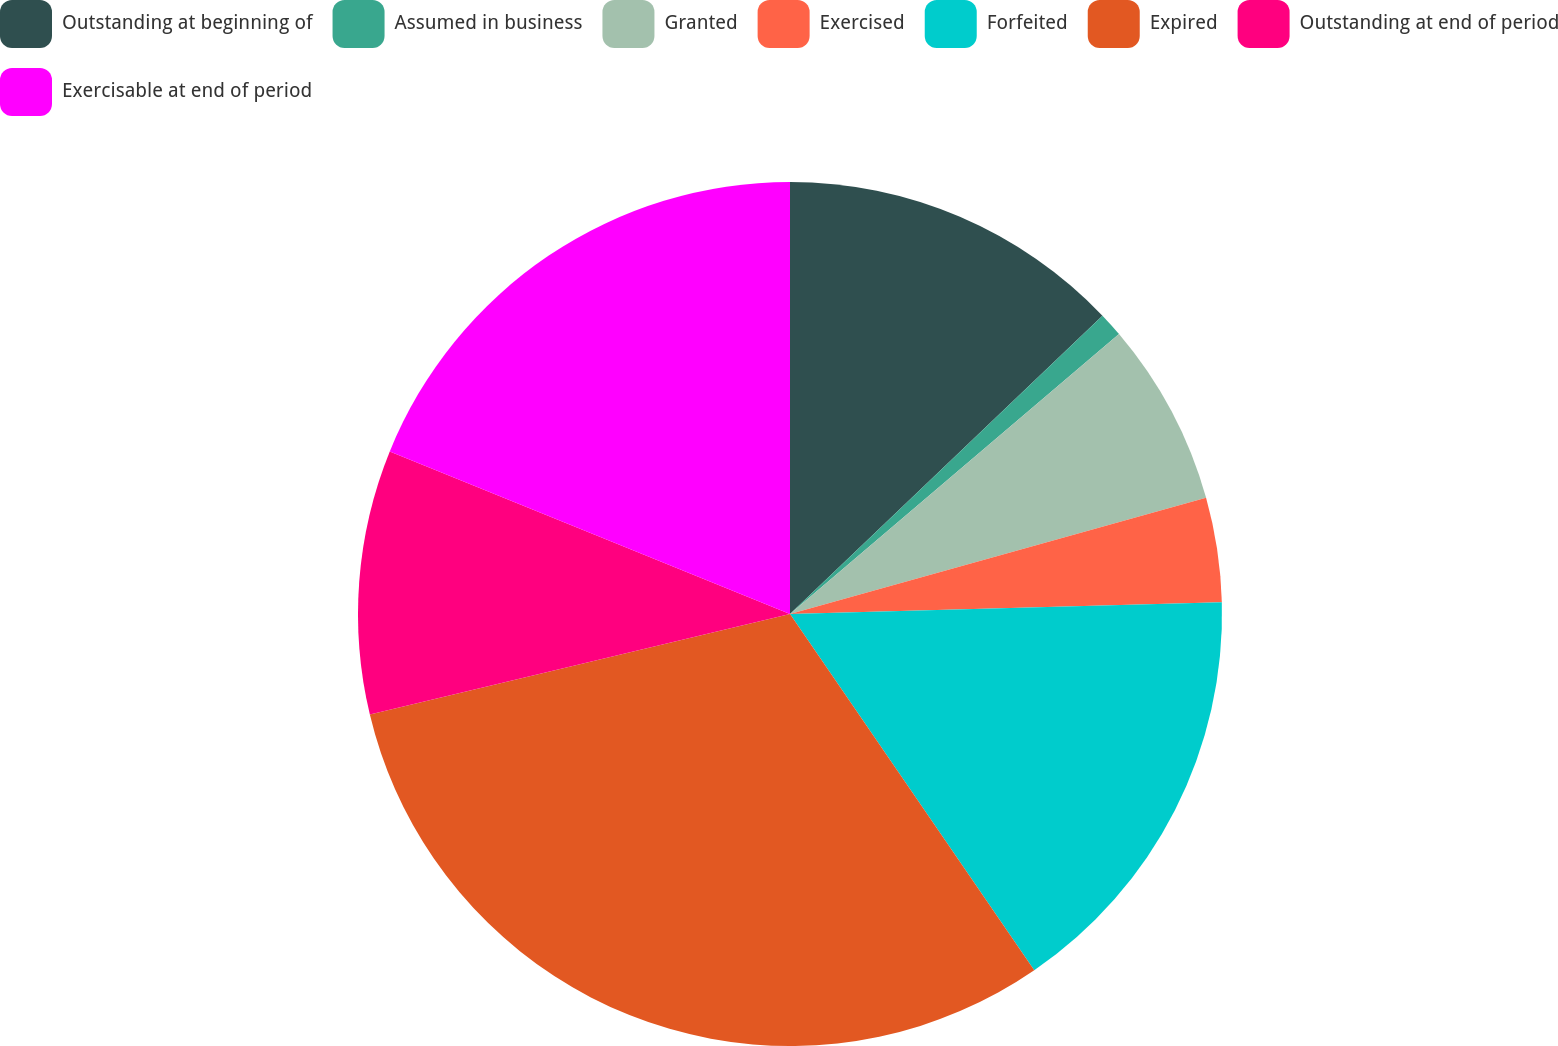Convert chart to OTSL. <chart><loc_0><loc_0><loc_500><loc_500><pie_chart><fcel>Outstanding at beginning of<fcel>Assumed in business<fcel>Granted<fcel>Exercised<fcel>Forfeited<fcel>Expired<fcel>Outstanding at end of period<fcel>Exercisable at end of period<nl><fcel>12.87%<fcel>0.91%<fcel>6.89%<fcel>3.9%<fcel>15.87%<fcel>30.83%<fcel>9.88%<fcel>18.86%<nl></chart> 